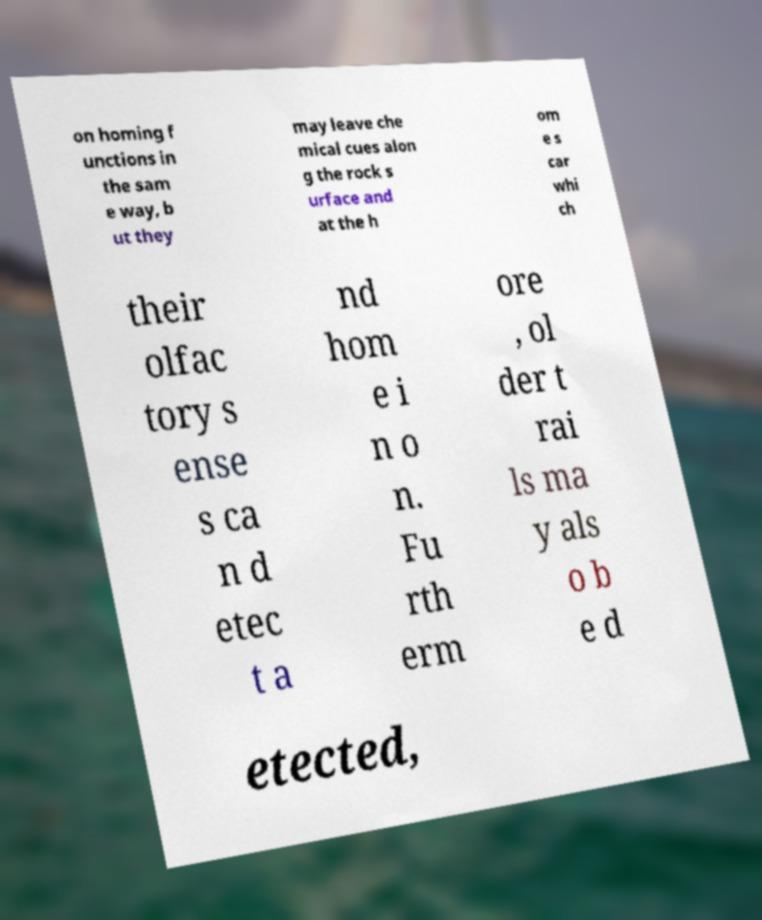There's text embedded in this image that I need extracted. Can you transcribe it verbatim? on homing f unctions in the sam e way, b ut they may leave che mical cues alon g the rock s urface and at the h om e s car whi ch their olfac tory s ense s ca n d etec t a nd hom e i n o n. Fu rth erm ore , ol der t rai ls ma y als o b e d etected, 